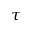<formula> <loc_0><loc_0><loc_500><loc_500>\tau</formula> 